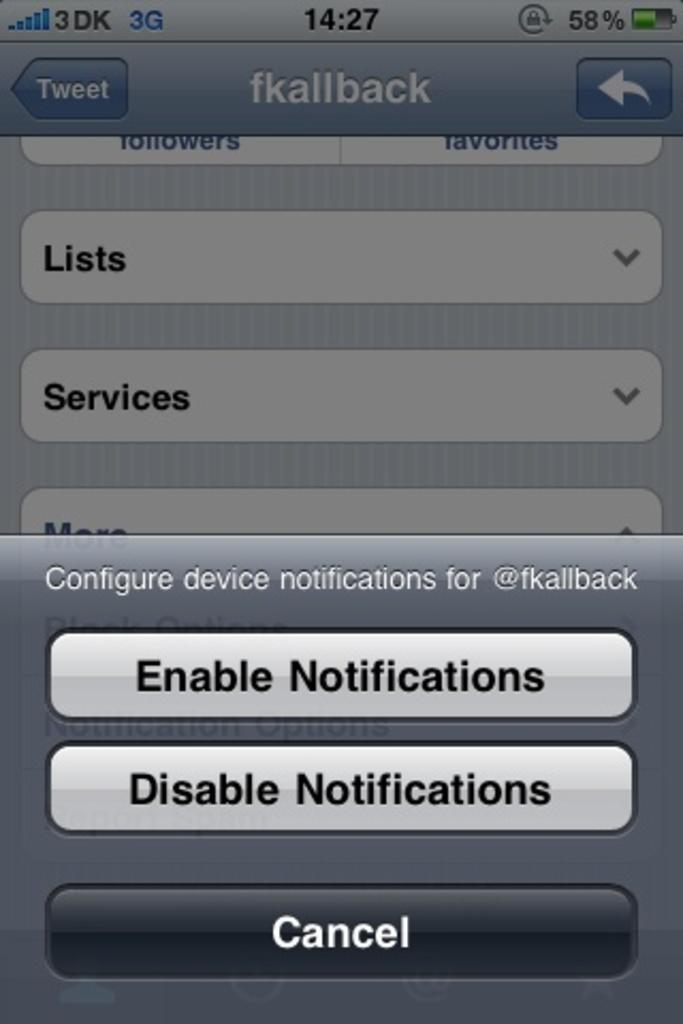Provide a one-sentence caption for the provided image. The screen of an iphone that allows for notification settings to be changed is displayed. 